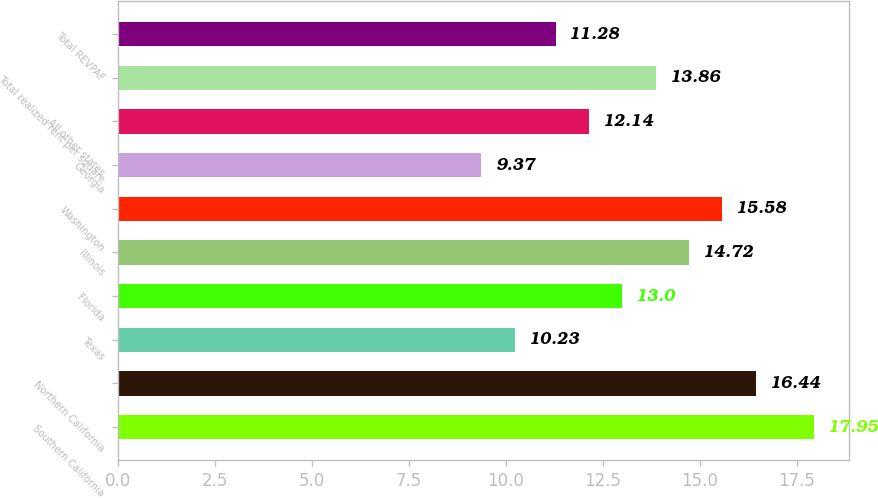<chart> <loc_0><loc_0><loc_500><loc_500><bar_chart><fcel>Southern California<fcel>Northern California<fcel>Texas<fcel>Florida<fcel>Illinois<fcel>Washington<fcel>Georgia<fcel>All other states<fcel>Total realized rent per square<fcel>Total REVPAF<nl><fcel>17.95<fcel>16.44<fcel>10.23<fcel>13<fcel>14.72<fcel>15.58<fcel>9.37<fcel>12.14<fcel>13.86<fcel>11.28<nl></chart> 